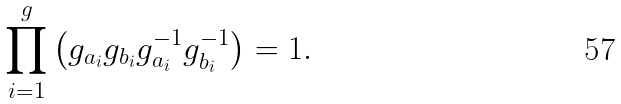<formula> <loc_0><loc_0><loc_500><loc_500>\prod _ { i = 1 } ^ { g } \left ( g _ { a _ { i } } g _ { b _ { i } } g _ { a _ { i } } ^ { - 1 } g _ { b _ { i } } ^ { - 1 } \right ) = 1 .</formula> 